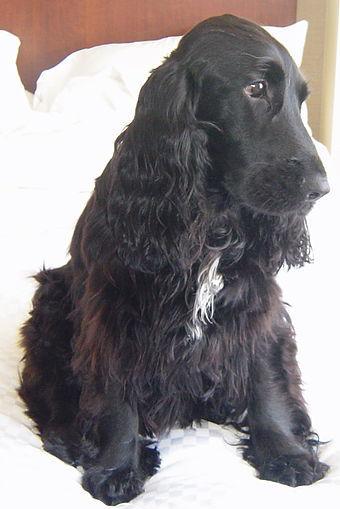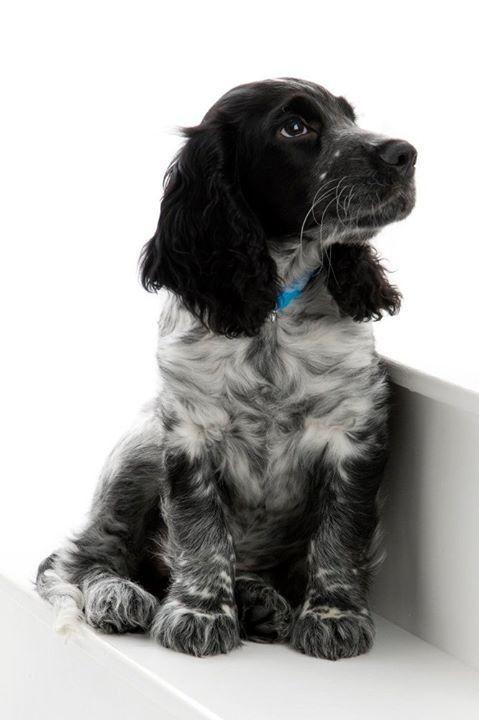The first image is the image on the left, the second image is the image on the right. Given the left and right images, does the statement "One of the images contains a black and white dog with its head turned to the right." hold true? Answer yes or no. Yes. The first image is the image on the left, the second image is the image on the right. Analyze the images presented: Is the assertion "in the right pic the dogs tongue can be seen" valid? Answer yes or no. No. 